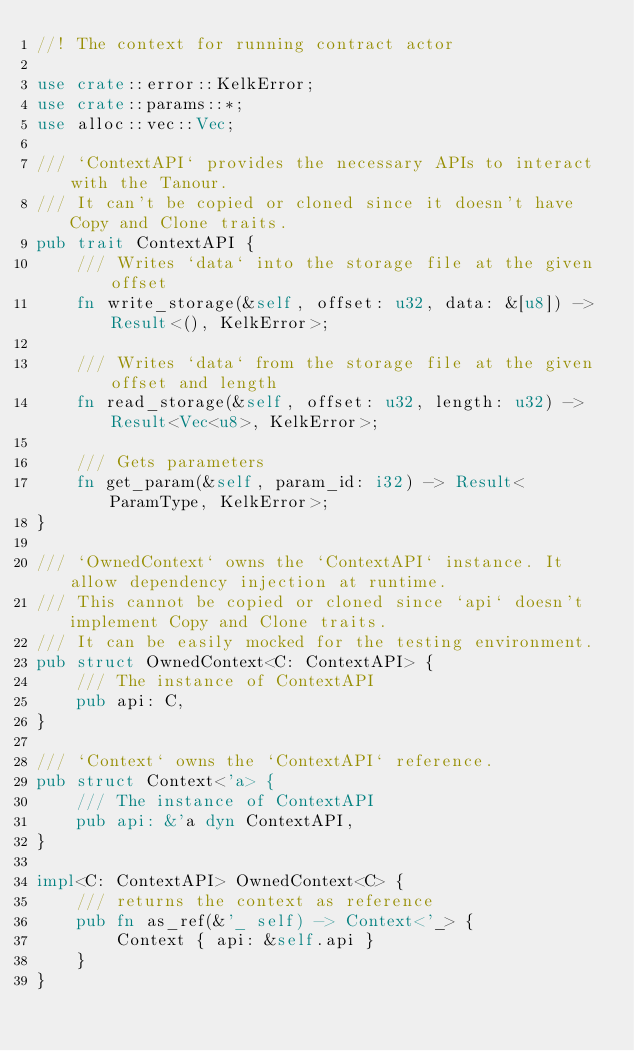<code> <loc_0><loc_0><loc_500><loc_500><_Rust_>//! The context for running contract actor

use crate::error::KelkError;
use crate::params::*;
use alloc::vec::Vec;

/// `ContextAPI` provides the necessary APIs to interact with the Tanour.
/// It can't be copied or cloned since it doesn't have Copy and Clone traits.
pub trait ContextAPI {
    /// Writes `data` into the storage file at the given offset
    fn write_storage(&self, offset: u32, data: &[u8]) -> Result<(), KelkError>;

    /// Writes `data` from the storage file at the given offset and length
    fn read_storage(&self, offset: u32, length: u32) -> Result<Vec<u8>, KelkError>;

    /// Gets parameters
    fn get_param(&self, param_id: i32) -> Result<ParamType, KelkError>;
}

/// `OwnedContext` owns the `ContextAPI` instance. It allow dependency injection at runtime.
/// This cannot be copied or cloned since `api` doesn't implement Copy and Clone traits.
/// It can be easily mocked for the testing environment.
pub struct OwnedContext<C: ContextAPI> {
    /// The instance of ContextAPI
    pub api: C,
}

/// `Context` owns the `ContextAPI` reference.
pub struct Context<'a> {
    /// The instance of ContextAPI
    pub api: &'a dyn ContextAPI,
}

impl<C: ContextAPI> OwnedContext<C> {
    /// returns the context as reference
    pub fn as_ref(&'_ self) -> Context<'_> {
        Context { api: &self.api }
    }
}
</code> 